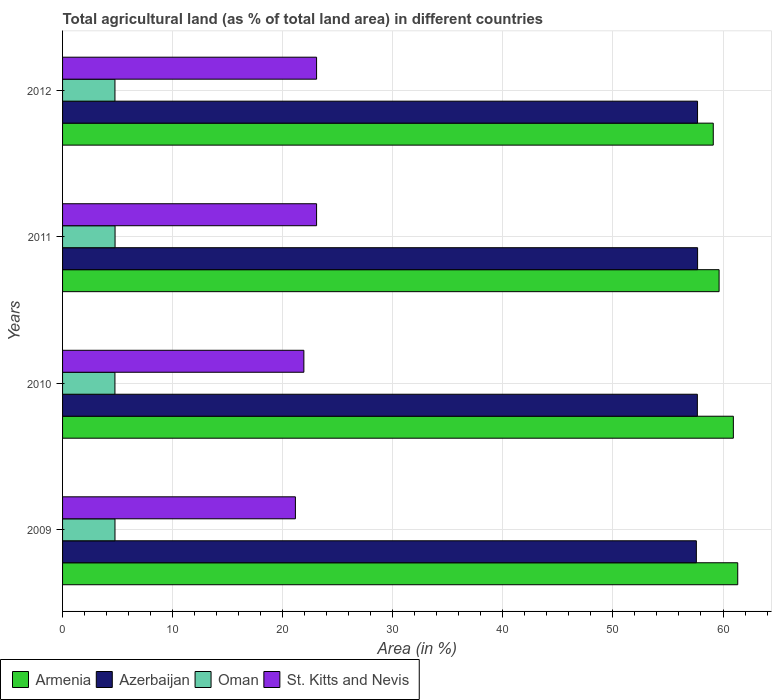How many groups of bars are there?
Give a very brief answer. 4. What is the label of the 4th group of bars from the top?
Provide a short and direct response. 2009. What is the percentage of agricultural land in St. Kitts and Nevis in 2010?
Your answer should be compact. 21.92. Across all years, what is the maximum percentage of agricultural land in Oman?
Make the answer very short. 4.77. Across all years, what is the minimum percentage of agricultural land in Azerbaijan?
Give a very brief answer. 57.58. In which year was the percentage of agricultural land in Azerbaijan maximum?
Give a very brief answer. 2011. What is the total percentage of agricultural land in Oman in the graph?
Your response must be concise. 19.05. What is the difference between the percentage of agricultural land in Armenia in 2009 and that in 2011?
Ensure brevity in your answer.  1.69. What is the difference between the percentage of agricultural land in Oman in 2011 and the percentage of agricultural land in St. Kitts and Nevis in 2012?
Your answer should be compact. -18.31. What is the average percentage of agricultural land in Azerbaijan per year?
Give a very brief answer. 57.66. In the year 2009, what is the difference between the percentage of agricultural land in St. Kitts and Nevis and percentage of agricultural land in Oman?
Ensure brevity in your answer.  16.39. In how many years, is the percentage of agricultural land in St. Kitts and Nevis greater than 54 %?
Provide a succinct answer. 0. What is the ratio of the percentage of agricultural land in St. Kitts and Nevis in 2009 to that in 2010?
Provide a succinct answer. 0.96. What is the difference between the highest and the second highest percentage of agricultural land in Armenia?
Offer a terse response. 0.4. What is the difference between the highest and the lowest percentage of agricultural land in Oman?
Your answer should be very brief. 0.01. Is the sum of the percentage of agricultural land in Azerbaijan in 2010 and 2012 greater than the maximum percentage of agricultural land in St. Kitts and Nevis across all years?
Make the answer very short. Yes. Is it the case that in every year, the sum of the percentage of agricultural land in Azerbaijan and percentage of agricultural land in Oman is greater than the sum of percentage of agricultural land in St. Kitts and Nevis and percentage of agricultural land in Armenia?
Your answer should be very brief. Yes. What does the 2nd bar from the top in 2012 represents?
Provide a short and direct response. Oman. What does the 1st bar from the bottom in 2011 represents?
Your answer should be very brief. Armenia. Is it the case that in every year, the sum of the percentage of agricultural land in Armenia and percentage of agricultural land in Oman is greater than the percentage of agricultural land in St. Kitts and Nevis?
Make the answer very short. Yes. Are all the bars in the graph horizontal?
Your answer should be compact. Yes. How many years are there in the graph?
Your response must be concise. 4. What is the difference between two consecutive major ticks on the X-axis?
Make the answer very short. 10. Does the graph contain any zero values?
Your response must be concise. No. Where does the legend appear in the graph?
Offer a terse response. Bottom left. How are the legend labels stacked?
Offer a terse response. Horizontal. What is the title of the graph?
Make the answer very short. Total agricultural land (as % of total land area) in different countries. What is the label or title of the X-axis?
Your response must be concise. Area (in %). What is the Area (in %) of Armenia in 2009?
Offer a terse response. 61.34. What is the Area (in %) of Azerbaijan in 2009?
Your answer should be very brief. 57.58. What is the Area (in %) of Oman in 2009?
Your answer should be very brief. 4.76. What is the Area (in %) in St. Kitts and Nevis in 2009?
Give a very brief answer. 21.15. What is the Area (in %) of Armenia in 2010?
Your response must be concise. 60.94. What is the Area (in %) of Azerbaijan in 2010?
Your answer should be compact. 57.67. What is the Area (in %) of Oman in 2010?
Your answer should be compact. 4.76. What is the Area (in %) in St. Kitts and Nevis in 2010?
Keep it short and to the point. 21.92. What is the Area (in %) of Armenia in 2011?
Make the answer very short. 59.65. What is the Area (in %) in Azerbaijan in 2011?
Make the answer very short. 57.69. What is the Area (in %) in Oman in 2011?
Your response must be concise. 4.77. What is the Area (in %) in St. Kitts and Nevis in 2011?
Keep it short and to the point. 23.08. What is the Area (in %) of Armenia in 2012?
Ensure brevity in your answer.  59.11. What is the Area (in %) in Azerbaijan in 2012?
Offer a very short reply. 57.69. What is the Area (in %) in Oman in 2012?
Your response must be concise. 4.76. What is the Area (in %) of St. Kitts and Nevis in 2012?
Make the answer very short. 23.08. Across all years, what is the maximum Area (in %) of Armenia?
Your response must be concise. 61.34. Across all years, what is the maximum Area (in %) in Azerbaijan?
Provide a succinct answer. 57.69. Across all years, what is the maximum Area (in %) in Oman?
Provide a succinct answer. 4.77. Across all years, what is the maximum Area (in %) of St. Kitts and Nevis?
Your answer should be very brief. 23.08. Across all years, what is the minimum Area (in %) of Armenia?
Ensure brevity in your answer.  59.11. Across all years, what is the minimum Area (in %) of Azerbaijan?
Make the answer very short. 57.58. Across all years, what is the minimum Area (in %) of Oman?
Offer a very short reply. 4.76. Across all years, what is the minimum Area (in %) in St. Kitts and Nevis?
Your answer should be very brief. 21.15. What is the total Area (in %) of Armenia in the graph?
Offer a terse response. 241.04. What is the total Area (in %) in Azerbaijan in the graph?
Your response must be concise. 230.63. What is the total Area (in %) in Oman in the graph?
Offer a very short reply. 19.05. What is the total Area (in %) in St. Kitts and Nevis in the graph?
Keep it short and to the point. 89.23. What is the difference between the Area (in %) in Armenia in 2009 and that in 2010?
Your answer should be compact. 0.4. What is the difference between the Area (in %) of Azerbaijan in 2009 and that in 2010?
Your response must be concise. -0.09. What is the difference between the Area (in %) in Oman in 2009 and that in 2010?
Give a very brief answer. 0. What is the difference between the Area (in %) in St. Kitts and Nevis in 2009 and that in 2010?
Your answer should be very brief. -0.77. What is the difference between the Area (in %) of Armenia in 2009 and that in 2011?
Give a very brief answer. 1.69. What is the difference between the Area (in %) of Azerbaijan in 2009 and that in 2011?
Make the answer very short. -0.11. What is the difference between the Area (in %) of Oman in 2009 and that in 2011?
Provide a short and direct response. -0.01. What is the difference between the Area (in %) of St. Kitts and Nevis in 2009 and that in 2011?
Your answer should be compact. -1.92. What is the difference between the Area (in %) in Armenia in 2009 and that in 2012?
Provide a short and direct response. 2.22. What is the difference between the Area (in %) of Azerbaijan in 2009 and that in 2012?
Your answer should be compact. -0.11. What is the difference between the Area (in %) in Oman in 2009 and that in 2012?
Your answer should be compact. 0. What is the difference between the Area (in %) of St. Kitts and Nevis in 2009 and that in 2012?
Ensure brevity in your answer.  -1.92. What is the difference between the Area (in %) of Armenia in 2010 and that in 2011?
Make the answer very short. 1.3. What is the difference between the Area (in %) in Azerbaijan in 2010 and that in 2011?
Provide a short and direct response. -0.02. What is the difference between the Area (in %) of Oman in 2010 and that in 2011?
Provide a succinct answer. -0.01. What is the difference between the Area (in %) of St. Kitts and Nevis in 2010 and that in 2011?
Give a very brief answer. -1.15. What is the difference between the Area (in %) in Armenia in 2010 and that in 2012?
Make the answer very short. 1.83. What is the difference between the Area (in %) of Azerbaijan in 2010 and that in 2012?
Your answer should be very brief. -0.02. What is the difference between the Area (in %) of Oman in 2010 and that in 2012?
Your response must be concise. -0. What is the difference between the Area (in %) in St. Kitts and Nevis in 2010 and that in 2012?
Offer a very short reply. -1.15. What is the difference between the Area (in %) of Armenia in 2011 and that in 2012?
Your response must be concise. 0.53. What is the difference between the Area (in %) in Azerbaijan in 2011 and that in 2012?
Keep it short and to the point. 0. What is the difference between the Area (in %) in Oman in 2011 and that in 2012?
Keep it short and to the point. 0.01. What is the difference between the Area (in %) in Armenia in 2009 and the Area (in %) in Azerbaijan in 2010?
Keep it short and to the point. 3.67. What is the difference between the Area (in %) of Armenia in 2009 and the Area (in %) of Oman in 2010?
Give a very brief answer. 56.58. What is the difference between the Area (in %) of Armenia in 2009 and the Area (in %) of St. Kitts and Nevis in 2010?
Offer a terse response. 39.42. What is the difference between the Area (in %) in Azerbaijan in 2009 and the Area (in %) in Oman in 2010?
Provide a short and direct response. 52.82. What is the difference between the Area (in %) in Azerbaijan in 2009 and the Area (in %) in St. Kitts and Nevis in 2010?
Your answer should be very brief. 35.66. What is the difference between the Area (in %) in Oman in 2009 and the Area (in %) in St. Kitts and Nevis in 2010?
Provide a succinct answer. -17.16. What is the difference between the Area (in %) in Armenia in 2009 and the Area (in %) in Azerbaijan in 2011?
Provide a succinct answer. 3.65. What is the difference between the Area (in %) in Armenia in 2009 and the Area (in %) in Oman in 2011?
Keep it short and to the point. 56.57. What is the difference between the Area (in %) of Armenia in 2009 and the Area (in %) of St. Kitts and Nevis in 2011?
Provide a succinct answer. 38.26. What is the difference between the Area (in %) in Azerbaijan in 2009 and the Area (in %) in Oman in 2011?
Your answer should be compact. 52.81. What is the difference between the Area (in %) of Azerbaijan in 2009 and the Area (in %) of St. Kitts and Nevis in 2011?
Your response must be concise. 34.5. What is the difference between the Area (in %) of Oman in 2009 and the Area (in %) of St. Kitts and Nevis in 2011?
Offer a very short reply. -18.31. What is the difference between the Area (in %) of Armenia in 2009 and the Area (in %) of Azerbaijan in 2012?
Ensure brevity in your answer.  3.65. What is the difference between the Area (in %) of Armenia in 2009 and the Area (in %) of Oman in 2012?
Offer a very short reply. 56.58. What is the difference between the Area (in %) of Armenia in 2009 and the Area (in %) of St. Kitts and Nevis in 2012?
Provide a succinct answer. 38.26. What is the difference between the Area (in %) in Azerbaijan in 2009 and the Area (in %) in Oman in 2012?
Your response must be concise. 52.82. What is the difference between the Area (in %) of Azerbaijan in 2009 and the Area (in %) of St. Kitts and Nevis in 2012?
Your response must be concise. 34.5. What is the difference between the Area (in %) in Oman in 2009 and the Area (in %) in St. Kitts and Nevis in 2012?
Your response must be concise. -18.31. What is the difference between the Area (in %) of Armenia in 2010 and the Area (in %) of Azerbaijan in 2011?
Ensure brevity in your answer.  3.25. What is the difference between the Area (in %) of Armenia in 2010 and the Area (in %) of Oman in 2011?
Make the answer very short. 56.17. What is the difference between the Area (in %) in Armenia in 2010 and the Area (in %) in St. Kitts and Nevis in 2011?
Offer a terse response. 37.86. What is the difference between the Area (in %) in Azerbaijan in 2010 and the Area (in %) in Oman in 2011?
Provide a succinct answer. 52.9. What is the difference between the Area (in %) of Azerbaijan in 2010 and the Area (in %) of St. Kitts and Nevis in 2011?
Your answer should be compact. 34.59. What is the difference between the Area (in %) of Oman in 2010 and the Area (in %) of St. Kitts and Nevis in 2011?
Give a very brief answer. -18.32. What is the difference between the Area (in %) in Armenia in 2010 and the Area (in %) in Azerbaijan in 2012?
Your response must be concise. 3.25. What is the difference between the Area (in %) of Armenia in 2010 and the Area (in %) of Oman in 2012?
Provide a short and direct response. 56.18. What is the difference between the Area (in %) in Armenia in 2010 and the Area (in %) in St. Kitts and Nevis in 2012?
Offer a terse response. 37.86. What is the difference between the Area (in %) in Azerbaijan in 2010 and the Area (in %) in Oman in 2012?
Your response must be concise. 52.91. What is the difference between the Area (in %) in Azerbaijan in 2010 and the Area (in %) in St. Kitts and Nevis in 2012?
Keep it short and to the point. 34.59. What is the difference between the Area (in %) in Oman in 2010 and the Area (in %) in St. Kitts and Nevis in 2012?
Your response must be concise. -18.32. What is the difference between the Area (in %) in Armenia in 2011 and the Area (in %) in Azerbaijan in 2012?
Keep it short and to the point. 1.96. What is the difference between the Area (in %) in Armenia in 2011 and the Area (in %) in Oman in 2012?
Offer a terse response. 54.89. What is the difference between the Area (in %) of Armenia in 2011 and the Area (in %) of St. Kitts and Nevis in 2012?
Offer a very short reply. 36.57. What is the difference between the Area (in %) of Azerbaijan in 2011 and the Area (in %) of Oman in 2012?
Ensure brevity in your answer.  52.93. What is the difference between the Area (in %) in Azerbaijan in 2011 and the Area (in %) in St. Kitts and Nevis in 2012?
Offer a very short reply. 34.62. What is the difference between the Area (in %) in Oman in 2011 and the Area (in %) in St. Kitts and Nevis in 2012?
Offer a very short reply. -18.31. What is the average Area (in %) in Armenia per year?
Your answer should be compact. 60.26. What is the average Area (in %) of Azerbaijan per year?
Provide a short and direct response. 57.66. What is the average Area (in %) in Oman per year?
Give a very brief answer. 4.76. What is the average Area (in %) of St. Kitts and Nevis per year?
Provide a succinct answer. 22.31. In the year 2009, what is the difference between the Area (in %) in Armenia and Area (in %) in Azerbaijan?
Provide a short and direct response. 3.76. In the year 2009, what is the difference between the Area (in %) of Armenia and Area (in %) of Oman?
Make the answer very short. 56.58. In the year 2009, what is the difference between the Area (in %) in Armenia and Area (in %) in St. Kitts and Nevis?
Provide a succinct answer. 40.18. In the year 2009, what is the difference between the Area (in %) of Azerbaijan and Area (in %) of Oman?
Offer a terse response. 52.82. In the year 2009, what is the difference between the Area (in %) of Azerbaijan and Area (in %) of St. Kitts and Nevis?
Give a very brief answer. 36.43. In the year 2009, what is the difference between the Area (in %) of Oman and Area (in %) of St. Kitts and Nevis?
Your answer should be compact. -16.39. In the year 2010, what is the difference between the Area (in %) of Armenia and Area (in %) of Azerbaijan?
Your answer should be compact. 3.27. In the year 2010, what is the difference between the Area (in %) of Armenia and Area (in %) of Oman?
Your answer should be very brief. 56.18. In the year 2010, what is the difference between the Area (in %) of Armenia and Area (in %) of St. Kitts and Nevis?
Your response must be concise. 39.02. In the year 2010, what is the difference between the Area (in %) in Azerbaijan and Area (in %) in Oman?
Offer a terse response. 52.91. In the year 2010, what is the difference between the Area (in %) in Azerbaijan and Area (in %) in St. Kitts and Nevis?
Ensure brevity in your answer.  35.75. In the year 2010, what is the difference between the Area (in %) of Oman and Area (in %) of St. Kitts and Nevis?
Keep it short and to the point. -17.17. In the year 2011, what is the difference between the Area (in %) in Armenia and Area (in %) in Azerbaijan?
Offer a very short reply. 1.95. In the year 2011, what is the difference between the Area (in %) of Armenia and Area (in %) of Oman?
Give a very brief answer. 54.88. In the year 2011, what is the difference between the Area (in %) in Armenia and Area (in %) in St. Kitts and Nevis?
Your answer should be very brief. 36.57. In the year 2011, what is the difference between the Area (in %) in Azerbaijan and Area (in %) in Oman?
Provide a succinct answer. 52.92. In the year 2011, what is the difference between the Area (in %) of Azerbaijan and Area (in %) of St. Kitts and Nevis?
Provide a short and direct response. 34.62. In the year 2011, what is the difference between the Area (in %) in Oman and Area (in %) in St. Kitts and Nevis?
Offer a terse response. -18.31. In the year 2012, what is the difference between the Area (in %) of Armenia and Area (in %) of Azerbaijan?
Your answer should be very brief. 1.43. In the year 2012, what is the difference between the Area (in %) of Armenia and Area (in %) of Oman?
Give a very brief answer. 54.36. In the year 2012, what is the difference between the Area (in %) of Armenia and Area (in %) of St. Kitts and Nevis?
Your response must be concise. 36.04. In the year 2012, what is the difference between the Area (in %) of Azerbaijan and Area (in %) of Oman?
Offer a very short reply. 52.93. In the year 2012, what is the difference between the Area (in %) of Azerbaijan and Area (in %) of St. Kitts and Nevis?
Offer a terse response. 34.61. In the year 2012, what is the difference between the Area (in %) of Oman and Area (in %) of St. Kitts and Nevis?
Provide a succinct answer. -18.32. What is the ratio of the Area (in %) in Armenia in 2009 to that in 2010?
Offer a very short reply. 1.01. What is the ratio of the Area (in %) of St. Kitts and Nevis in 2009 to that in 2010?
Your response must be concise. 0.96. What is the ratio of the Area (in %) in Armenia in 2009 to that in 2011?
Provide a succinct answer. 1.03. What is the ratio of the Area (in %) of Oman in 2009 to that in 2011?
Give a very brief answer. 1. What is the ratio of the Area (in %) in Armenia in 2009 to that in 2012?
Provide a short and direct response. 1.04. What is the ratio of the Area (in %) of St. Kitts and Nevis in 2009 to that in 2012?
Keep it short and to the point. 0.92. What is the ratio of the Area (in %) of Armenia in 2010 to that in 2011?
Give a very brief answer. 1.02. What is the ratio of the Area (in %) of Azerbaijan in 2010 to that in 2011?
Give a very brief answer. 1. What is the ratio of the Area (in %) of St. Kitts and Nevis in 2010 to that in 2011?
Provide a succinct answer. 0.95. What is the ratio of the Area (in %) of Armenia in 2010 to that in 2012?
Offer a very short reply. 1.03. What is the ratio of the Area (in %) in Oman in 2010 to that in 2012?
Ensure brevity in your answer.  1. What is the ratio of the Area (in %) of St. Kitts and Nevis in 2010 to that in 2012?
Provide a short and direct response. 0.95. What is the ratio of the Area (in %) of Armenia in 2011 to that in 2012?
Keep it short and to the point. 1.01. What is the ratio of the Area (in %) in Azerbaijan in 2011 to that in 2012?
Your answer should be compact. 1. What is the ratio of the Area (in %) of St. Kitts and Nevis in 2011 to that in 2012?
Provide a short and direct response. 1. What is the difference between the highest and the second highest Area (in %) in Armenia?
Offer a terse response. 0.4. What is the difference between the highest and the second highest Area (in %) of Azerbaijan?
Ensure brevity in your answer.  0. What is the difference between the highest and the second highest Area (in %) of Oman?
Ensure brevity in your answer.  0.01. What is the difference between the highest and the second highest Area (in %) in St. Kitts and Nevis?
Give a very brief answer. 0. What is the difference between the highest and the lowest Area (in %) in Armenia?
Ensure brevity in your answer.  2.22. What is the difference between the highest and the lowest Area (in %) in Azerbaijan?
Your response must be concise. 0.11. What is the difference between the highest and the lowest Area (in %) of Oman?
Give a very brief answer. 0.01. What is the difference between the highest and the lowest Area (in %) in St. Kitts and Nevis?
Give a very brief answer. 1.92. 